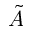Convert formula to latex. <formula><loc_0><loc_0><loc_500><loc_500>\tilde { A }</formula> 